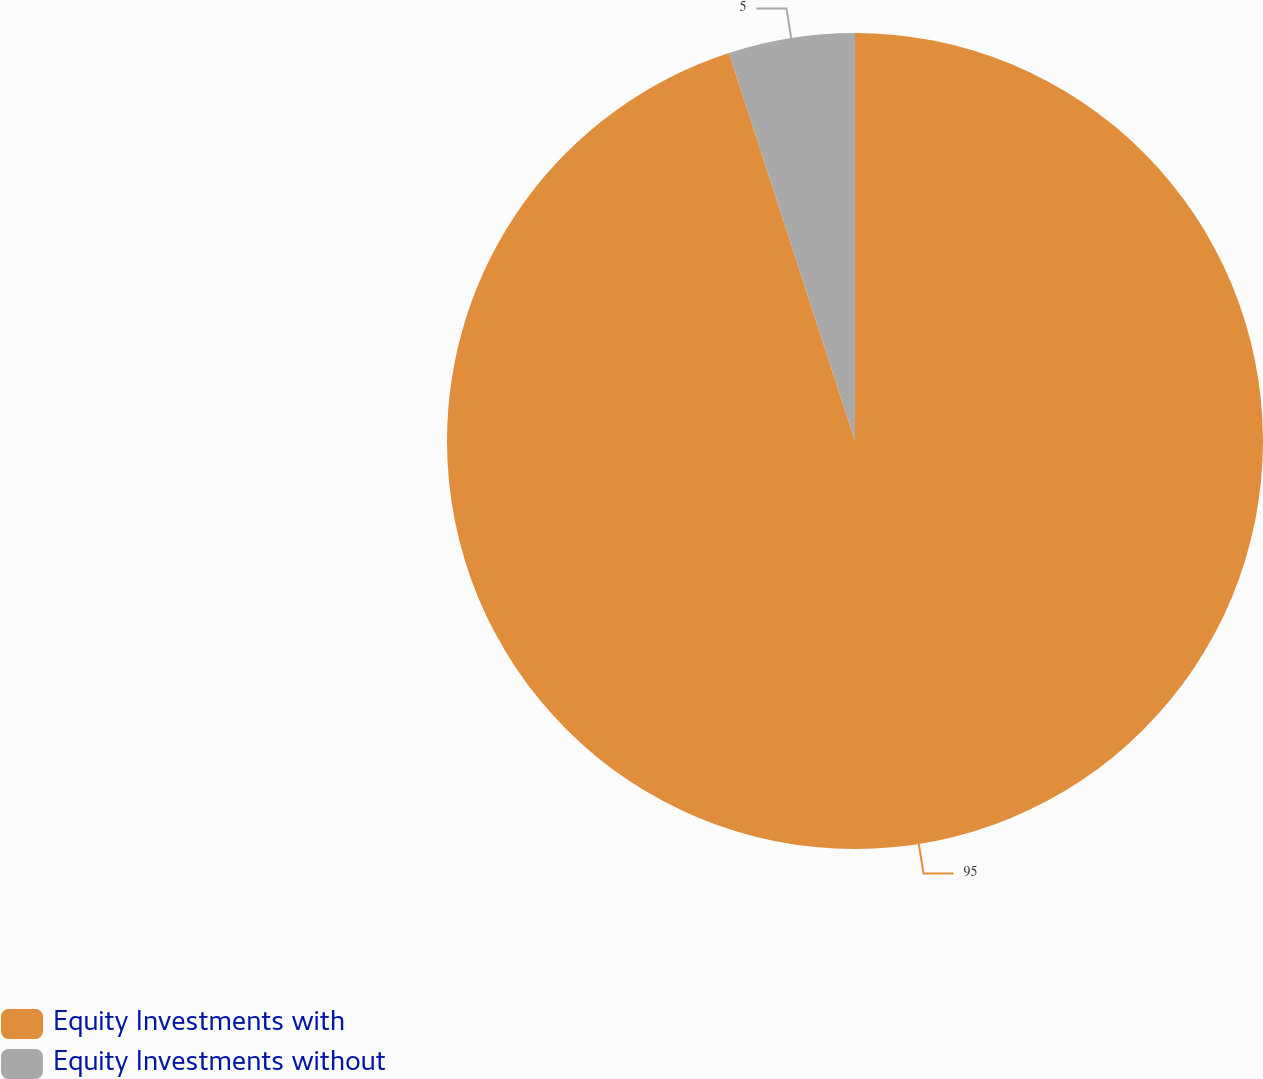<chart> <loc_0><loc_0><loc_500><loc_500><pie_chart><fcel>Equity Investments with<fcel>Equity Investments without<nl><fcel>95.0%<fcel>5.0%<nl></chart> 